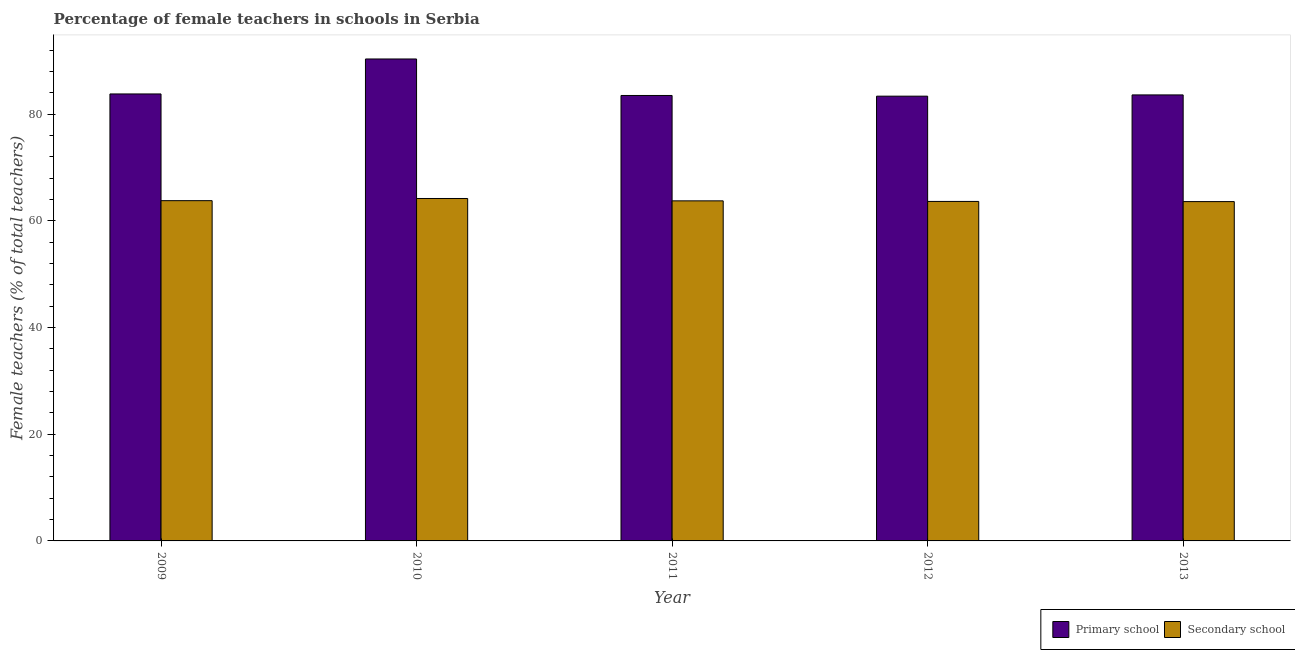How many different coloured bars are there?
Make the answer very short. 2. How many groups of bars are there?
Your response must be concise. 5. Are the number of bars per tick equal to the number of legend labels?
Provide a short and direct response. Yes. How many bars are there on the 4th tick from the right?
Your answer should be compact. 2. What is the percentage of female teachers in primary schools in 2010?
Keep it short and to the point. 90.35. Across all years, what is the maximum percentage of female teachers in secondary schools?
Your response must be concise. 64.19. Across all years, what is the minimum percentage of female teachers in secondary schools?
Your answer should be very brief. 63.61. In which year was the percentage of female teachers in secondary schools maximum?
Your answer should be very brief. 2010. What is the total percentage of female teachers in secondary schools in the graph?
Provide a short and direct response. 318.98. What is the difference between the percentage of female teachers in secondary schools in 2010 and that in 2013?
Provide a short and direct response. 0.58. What is the difference between the percentage of female teachers in primary schools in 2013 and the percentage of female teachers in secondary schools in 2010?
Offer a very short reply. -6.74. What is the average percentage of female teachers in secondary schools per year?
Keep it short and to the point. 63.8. In the year 2010, what is the difference between the percentage of female teachers in primary schools and percentage of female teachers in secondary schools?
Give a very brief answer. 0. What is the ratio of the percentage of female teachers in secondary schools in 2012 to that in 2013?
Your answer should be very brief. 1. Is the percentage of female teachers in primary schools in 2010 less than that in 2012?
Your response must be concise. No. What is the difference between the highest and the second highest percentage of female teachers in secondary schools?
Offer a very short reply. 0.41. What is the difference between the highest and the lowest percentage of female teachers in primary schools?
Provide a succinct answer. 6.97. In how many years, is the percentage of female teachers in primary schools greater than the average percentage of female teachers in primary schools taken over all years?
Make the answer very short. 1. What does the 2nd bar from the left in 2009 represents?
Your response must be concise. Secondary school. What does the 2nd bar from the right in 2013 represents?
Offer a terse response. Primary school. How many years are there in the graph?
Ensure brevity in your answer.  5. What is the difference between two consecutive major ticks on the Y-axis?
Provide a short and direct response. 20. Does the graph contain grids?
Provide a succinct answer. No. Where does the legend appear in the graph?
Provide a short and direct response. Bottom right. How many legend labels are there?
Your answer should be very brief. 2. How are the legend labels stacked?
Offer a very short reply. Horizontal. What is the title of the graph?
Your answer should be compact. Percentage of female teachers in schools in Serbia. What is the label or title of the Y-axis?
Your response must be concise. Female teachers (% of total teachers). What is the Female teachers (% of total teachers) of Primary school in 2009?
Keep it short and to the point. 83.79. What is the Female teachers (% of total teachers) in Secondary school in 2009?
Ensure brevity in your answer.  63.79. What is the Female teachers (% of total teachers) in Primary school in 2010?
Provide a succinct answer. 90.35. What is the Female teachers (% of total teachers) in Secondary school in 2010?
Offer a terse response. 64.19. What is the Female teachers (% of total teachers) of Primary school in 2011?
Your response must be concise. 83.5. What is the Female teachers (% of total teachers) in Secondary school in 2011?
Your answer should be compact. 63.75. What is the Female teachers (% of total teachers) of Primary school in 2012?
Offer a very short reply. 83.38. What is the Female teachers (% of total teachers) of Secondary school in 2012?
Give a very brief answer. 63.64. What is the Female teachers (% of total teachers) in Primary school in 2013?
Offer a terse response. 83.61. What is the Female teachers (% of total teachers) of Secondary school in 2013?
Give a very brief answer. 63.61. Across all years, what is the maximum Female teachers (% of total teachers) of Primary school?
Make the answer very short. 90.35. Across all years, what is the maximum Female teachers (% of total teachers) of Secondary school?
Your response must be concise. 64.19. Across all years, what is the minimum Female teachers (% of total teachers) in Primary school?
Give a very brief answer. 83.38. Across all years, what is the minimum Female teachers (% of total teachers) in Secondary school?
Provide a short and direct response. 63.61. What is the total Female teachers (% of total teachers) of Primary school in the graph?
Offer a very short reply. 424.64. What is the total Female teachers (% of total teachers) of Secondary school in the graph?
Give a very brief answer. 318.98. What is the difference between the Female teachers (% of total teachers) in Primary school in 2009 and that in 2010?
Keep it short and to the point. -6.56. What is the difference between the Female teachers (% of total teachers) of Secondary school in 2009 and that in 2010?
Your response must be concise. -0.41. What is the difference between the Female teachers (% of total teachers) in Primary school in 2009 and that in 2011?
Make the answer very short. 0.29. What is the difference between the Female teachers (% of total teachers) in Secondary school in 2009 and that in 2011?
Give a very brief answer. 0.04. What is the difference between the Female teachers (% of total teachers) in Primary school in 2009 and that in 2012?
Offer a very short reply. 0.42. What is the difference between the Female teachers (% of total teachers) of Secondary school in 2009 and that in 2012?
Your answer should be compact. 0.14. What is the difference between the Female teachers (% of total teachers) of Primary school in 2009 and that in 2013?
Offer a terse response. 0.18. What is the difference between the Female teachers (% of total teachers) of Secondary school in 2009 and that in 2013?
Give a very brief answer. 0.17. What is the difference between the Female teachers (% of total teachers) of Primary school in 2010 and that in 2011?
Ensure brevity in your answer.  6.84. What is the difference between the Female teachers (% of total teachers) of Secondary school in 2010 and that in 2011?
Your answer should be compact. 0.44. What is the difference between the Female teachers (% of total teachers) of Primary school in 2010 and that in 2012?
Provide a short and direct response. 6.97. What is the difference between the Female teachers (% of total teachers) in Secondary school in 2010 and that in 2012?
Keep it short and to the point. 0.55. What is the difference between the Female teachers (% of total teachers) in Primary school in 2010 and that in 2013?
Provide a succinct answer. 6.74. What is the difference between the Female teachers (% of total teachers) of Secondary school in 2010 and that in 2013?
Ensure brevity in your answer.  0.58. What is the difference between the Female teachers (% of total teachers) in Primary school in 2011 and that in 2012?
Make the answer very short. 0.13. What is the difference between the Female teachers (% of total teachers) in Secondary school in 2011 and that in 2012?
Your answer should be compact. 0.11. What is the difference between the Female teachers (% of total teachers) of Primary school in 2011 and that in 2013?
Ensure brevity in your answer.  -0.11. What is the difference between the Female teachers (% of total teachers) in Secondary school in 2011 and that in 2013?
Your answer should be compact. 0.14. What is the difference between the Female teachers (% of total teachers) in Primary school in 2012 and that in 2013?
Give a very brief answer. -0.23. What is the difference between the Female teachers (% of total teachers) of Secondary school in 2012 and that in 2013?
Offer a terse response. 0.03. What is the difference between the Female teachers (% of total teachers) in Primary school in 2009 and the Female teachers (% of total teachers) in Secondary school in 2010?
Offer a terse response. 19.6. What is the difference between the Female teachers (% of total teachers) in Primary school in 2009 and the Female teachers (% of total teachers) in Secondary school in 2011?
Offer a terse response. 20.04. What is the difference between the Female teachers (% of total teachers) in Primary school in 2009 and the Female teachers (% of total teachers) in Secondary school in 2012?
Your answer should be compact. 20.15. What is the difference between the Female teachers (% of total teachers) of Primary school in 2009 and the Female teachers (% of total teachers) of Secondary school in 2013?
Offer a very short reply. 20.18. What is the difference between the Female teachers (% of total teachers) in Primary school in 2010 and the Female teachers (% of total teachers) in Secondary school in 2011?
Make the answer very short. 26.6. What is the difference between the Female teachers (% of total teachers) of Primary school in 2010 and the Female teachers (% of total teachers) of Secondary school in 2012?
Ensure brevity in your answer.  26.71. What is the difference between the Female teachers (% of total teachers) of Primary school in 2010 and the Female teachers (% of total teachers) of Secondary school in 2013?
Ensure brevity in your answer.  26.74. What is the difference between the Female teachers (% of total teachers) in Primary school in 2011 and the Female teachers (% of total teachers) in Secondary school in 2012?
Offer a very short reply. 19.86. What is the difference between the Female teachers (% of total teachers) of Primary school in 2011 and the Female teachers (% of total teachers) of Secondary school in 2013?
Make the answer very short. 19.89. What is the difference between the Female teachers (% of total teachers) in Primary school in 2012 and the Female teachers (% of total teachers) in Secondary school in 2013?
Your answer should be compact. 19.77. What is the average Female teachers (% of total teachers) of Primary school per year?
Offer a terse response. 84.93. What is the average Female teachers (% of total teachers) of Secondary school per year?
Ensure brevity in your answer.  63.8. In the year 2009, what is the difference between the Female teachers (% of total teachers) of Primary school and Female teachers (% of total teachers) of Secondary school?
Your answer should be compact. 20.01. In the year 2010, what is the difference between the Female teachers (% of total teachers) of Primary school and Female teachers (% of total teachers) of Secondary school?
Give a very brief answer. 26.15. In the year 2011, what is the difference between the Female teachers (% of total teachers) in Primary school and Female teachers (% of total teachers) in Secondary school?
Your response must be concise. 19.75. In the year 2012, what is the difference between the Female teachers (% of total teachers) in Primary school and Female teachers (% of total teachers) in Secondary school?
Your answer should be very brief. 19.73. In the year 2013, what is the difference between the Female teachers (% of total teachers) of Primary school and Female teachers (% of total teachers) of Secondary school?
Ensure brevity in your answer.  20. What is the ratio of the Female teachers (% of total teachers) of Primary school in 2009 to that in 2010?
Make the answer very short. 0.93. What is the ratio of the Female teachers (% of total teachers) in Primary school in 2009 to that in 2011?
Your answer should be very brief. 1. What is the ratio of the Female teachers (% of total teachers) in Secondary school in 2009 to that in 2013?
Your response must be concise. 1. What is the ratio of the Female teachers (% of total teachers) in Primary school in 2010 to that in 2011?
Your answer should be very brief. 1.08. What is the ratio of the Female teachers (% of total teachers) of Secondary school in 2010 to that in 2011?
Keep it short and to the point. 1.01. What is the ratio of the Female teachers (% of total teachers) in Primary school in 2010 to that in 2012?
Offer a terse response. 1.08. What is the ratio of the Female teachers (% of total teachers) in Secondary school in 2010 to that in 2012?
Your answer should be very brief. 1.01. What is the ratio of the Female teachers (% of total teachers) of Primary school in 2010 to that in 2013?
Make the answer very short. 1.08. What is the ratio of the Female teachers (% of total teachers) of Secondary school in 2010 to that in 2013?
Offer a terse response. 1.01. What is the ratio of the Female teachers (% of total teachers) of Secondary school in 2011 to that in 2012?
Offer a terse response. 1. What is the ratio of the Female teachers (% of total teachers) of Secondary school in 2011 to that in 2013?
Offer a terse response. 1. What is the difference between the highest and the second highest Female teachers (% of total teachers) of Primary school?
Your answer should be very brief. 6.56. What is the difference between the highest and the second highest Female teachers (% of total teachers) of Secondary school?
Your answer should be very brief. 0.41. What is the difference between the highest and the lowest Female teachers (% of total teachers) of Primary school?
Offer a very short reply. 6.97. What is the difference between the highest and the lowest Female teachers (% of total teachers) of Secondary school?
Give a very brief answer. 0.58. 